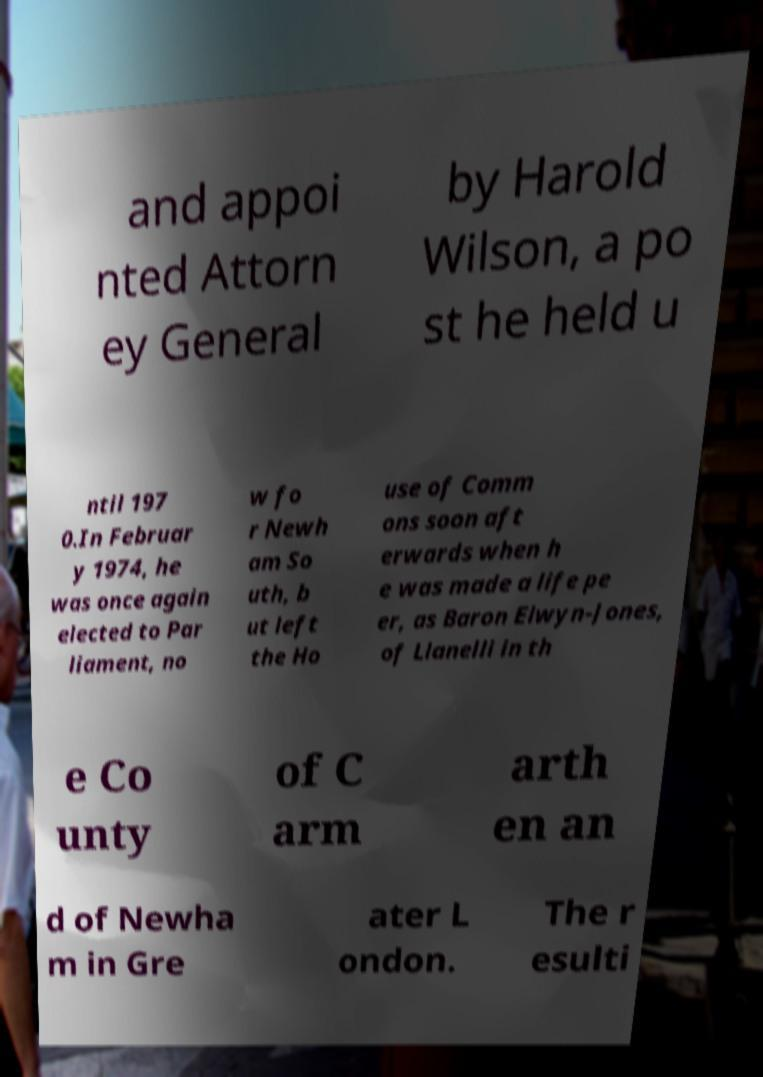What messages or text are displayed in this image? I need them in a readable, typed format. and appoi nted Attorn ey General by Harold Wilson, a po st he held u ntil 197 0.In Februar y 1974, he was once again elected to Par liament, no w fo r Newh am So uth, b ut left the Ho use of Comm ons soon aft erwards when h e was made a life pe er, as Baron Elwyn-Jones, of Llanelli in th e Co unty of C arm arth en an d of Newha m in Gre ater L ondon. The r esulti 